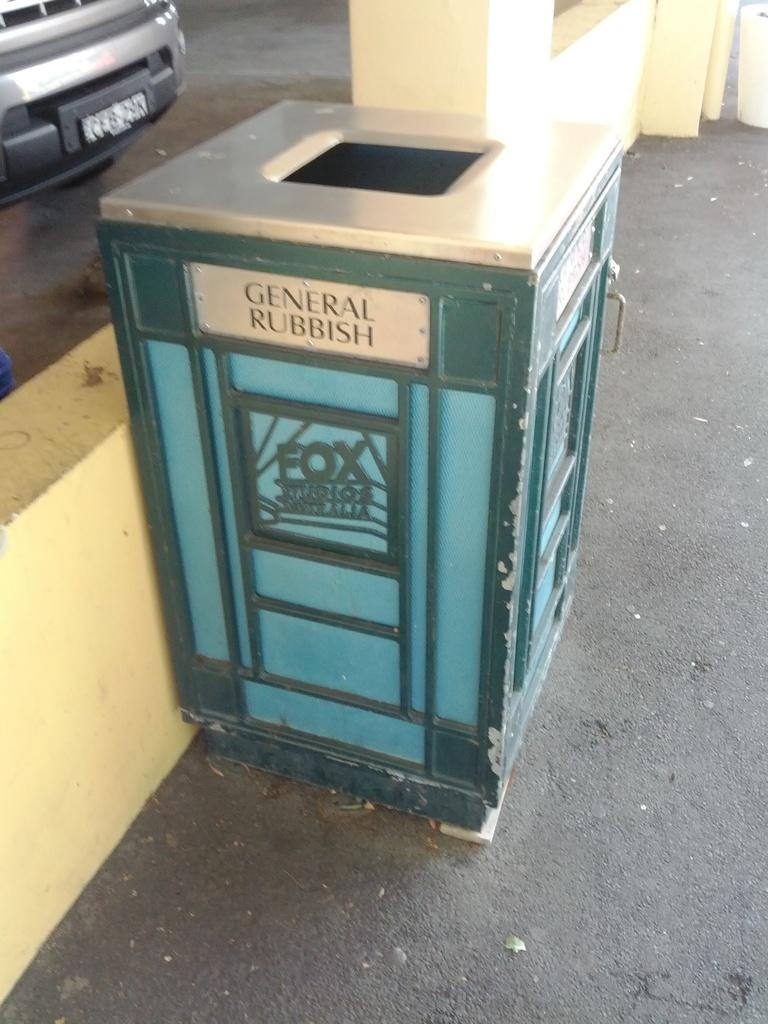What object is present in the image that is used for waste disposal? There is a trash bin in the image. Where is the trash bin located in relation to the ground? The trash bin is placed on the ground. What type of structure can be seen in the background of the image? There is a wall in the image. What type of vehicle is parked in the image? There is a car parked in the image. What type of actor is standing next to the car in the image? There is no actor present in the image; it only features a trash bin, a wall, and a parked car. 